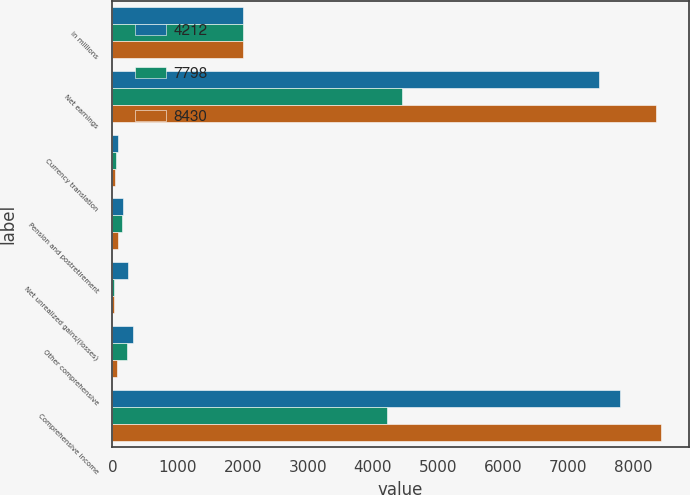<chart> <loc_0><loc_0><loc_500><loc_500><stacked_bar_chart><ecel><fcel>in millions<fcel>Net earnings<fcel>Currency translation<fcel>Pension and postretirement<fcel>Net unrealized gains/(losses)<fcel>Other comprehensive<fcel>Comprehensive income<nl><fcel>4212<fcel>2012<fcel>7475<fcel>89<fcel>168<fcel>244<fcel>323<fcel>7798<nl><fcel>7798<fcel>2011<fcel>4442<fcel>55<fcel>145<fcel>30<fcel>230<fcel>4212<nl><fcel>8430<fcel>2010<fcel>8354<fcel>38<fcel>88<fcel>26<fcel>76<fcel>8430<nl></chart> 